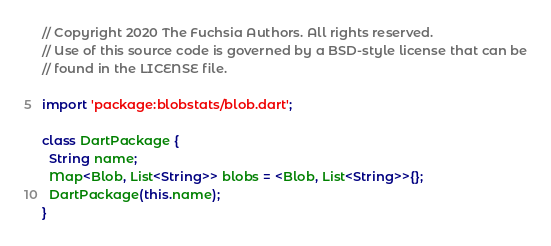Convert code to text. <code><loc_0><loc_0><loc_500><loc_500><_Dart_>// Copyright 2020 The Fuchsia Authors. All rights reserved.
// Use of this source code is governed by a BSD-style license that can be
// found in the LICENSE file.

import 'package:blobstats/blob.dart';

class DartPackage {
  String name;
  Map<Blob, List<String>> blobs = <Blob, List<String>>{};
  DartPackage(this.name);
}
</code> 